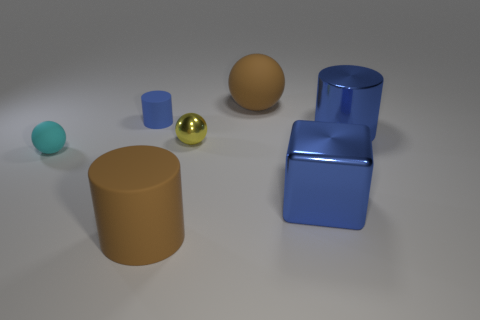How many blue cylinders must be subtracted to get 1 blue cylinders? 1 Add 3 big rubber cylinders. How many objects exist? 10 Subtract all cyan rubber balls. How many balls are left? 2 Subtract all green spheres. How many blue cylinders are left? 2 Subtract 1 spheres. How many spheres are left? 2 Subtract all blue cylinders. How many cylinders are left? 1 Subtract all spheres. How many objects are left? 4 Add 5 small cyan rubber things. How many small cyan rubber things are left? 6 Add 6 small red shiny things. How many small red shiny things exist? 6 Subtract 0 blue balls. How many objects are left? 7 